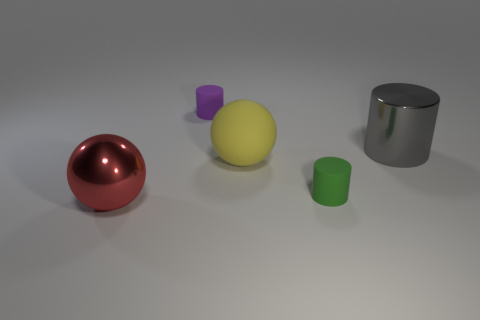Is there anything else that is the same shape as the red thing?
Provide a short and direct response. Yes. How many rubber objects are either small purple cylinders or tiny cylinders?
Ensure brevity in your answer.  2. Are there fewer large matte things that are left of the small purple thing than red matte cylinders?
Ensure brevity in your answer.  No. There is a large shiny thing that is in front of the ball right of the large metallic object in front of the gray metal cylinder; what is its shape?
Your answer should be very brief. Sphere. Do the large rubber sphere and the big cylinder have the same color?
Give a very brief answer. No. Is the number of red things greater than the number of red matte cubes?
Provide a succinct answer. Yes. How many other objects are there of the same material as the large red ball?
Offer a terse response. 1. How many objects are small things or objects that are to the left of the big cylinder?
Provide a short and direct response. 4. Are there fewer large rubber balls than blue metallic objects?
Offer a very short reply. No. The metallic thing that is behind the big metallic thing that is to the left of the big gray metallic thing that is in front of the tiny purple rubber thing is what color?
Provide a short and direct response. Gray. 